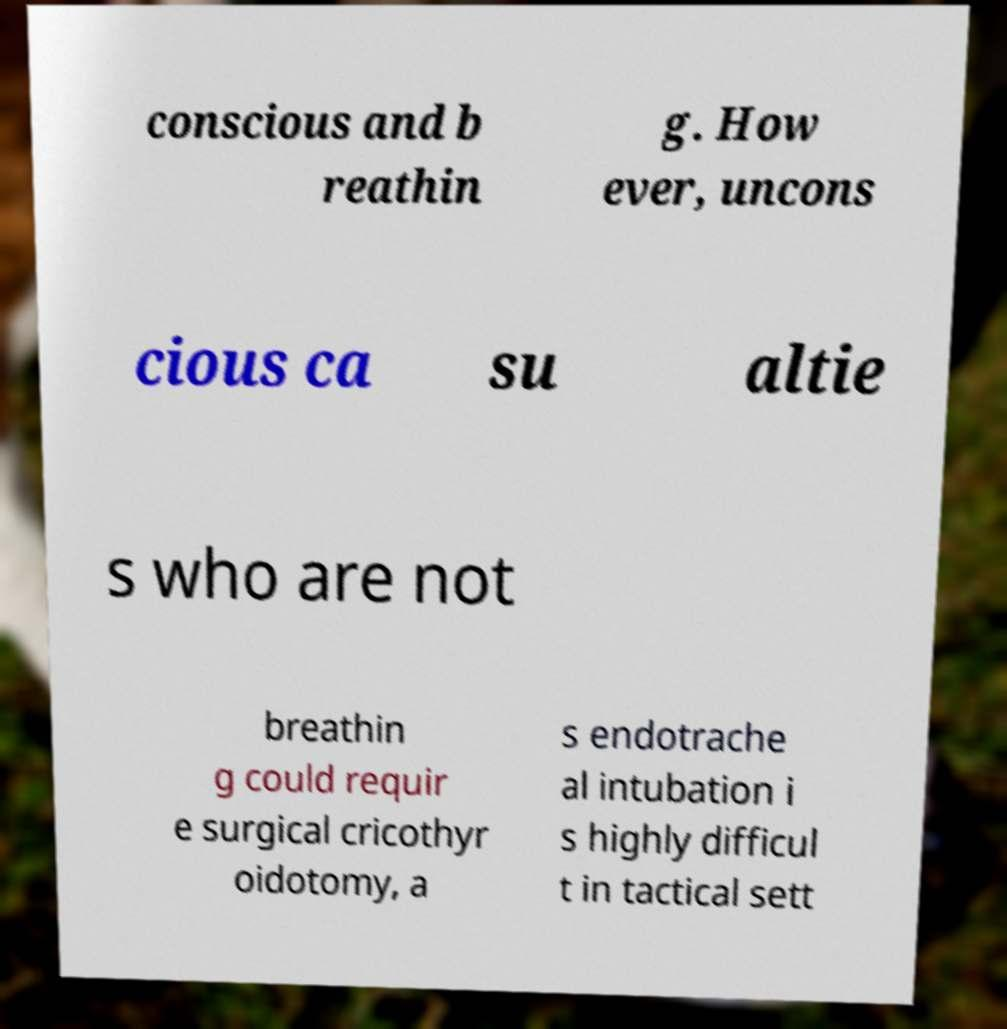Could you extract and type out the text from this image? conscious and b reathin g. How ever, uncons cious ca su altie s who are not breathin g could requir e surgical cricothyr oidotomy, a s endotrache al intubation i s highly difficul t in tactical sett 